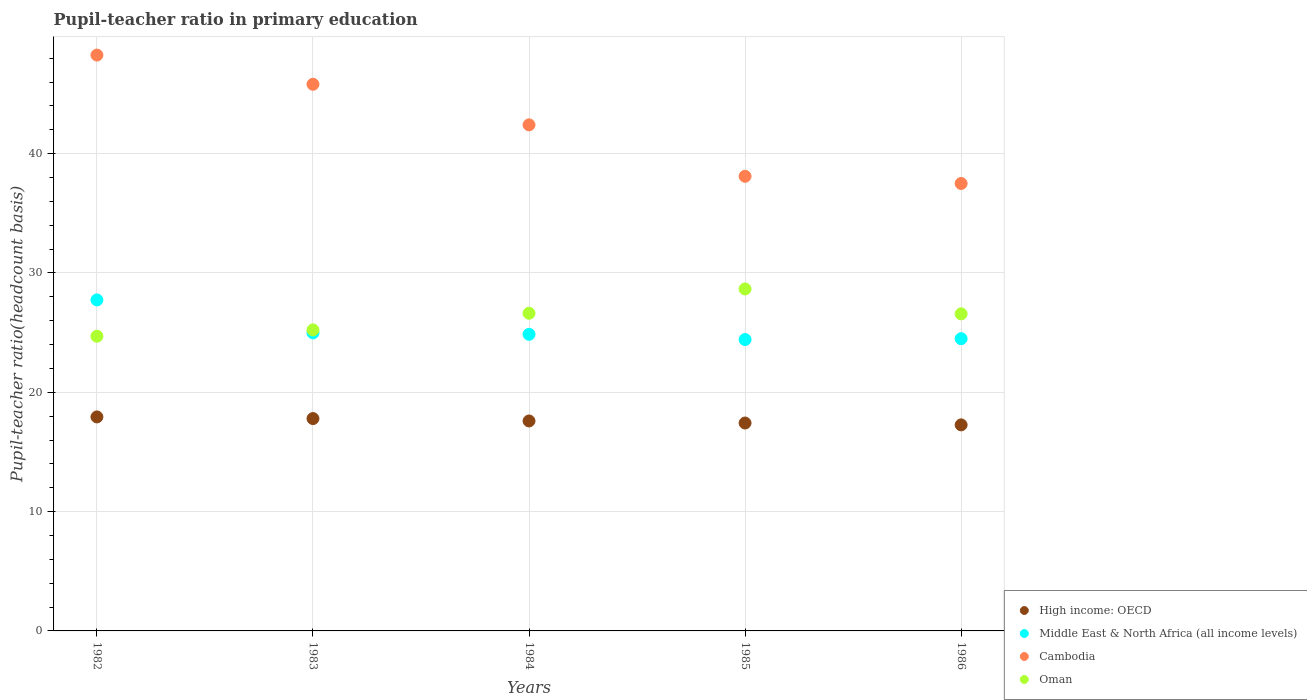What is the pupil-teacher ratio in primary education in Cambodia in 1983?
Keep it short and to the point. 45.82. Across all years, what is the maximum pupil-teacher ratio in primary education in Middle East & North Africa (all income levels)?
Your answer should be very brief. 27.74. Across all years, what is the minimum pupil-teacher ratio in primary education in Oman?
Provide a short and direct response. 24.7. In which year was the pupil-teacher ratio in primary education in High income: OECD maximum?
Give a very brief answer. 1982. In which year was the pupil-teacher ratio in primary education in Cambodia minimum?
Make the answer very short. 1986. What is the total pupil-teacher ratio in primary education in Cambodia in the graph?
Provide a succinct answer. 212.1. What is the difference between the pupil-teacher ratio in primary education in Middle East & North Africa (all income levels) in 1982 and that in 1983?
Provide a succinct answer. 2.76. What is the difference between the pupil-teacher ratio in primary education in Oman in 1985 and the pupil-teacher ratio in primary education in Cambodia in 1983?
Offer a terse response. -17.15. What is the average pupil-teacher ratio in primary education in Middle East & North Africa (all income levels) per year?
Ensure brevity in your answer.  25.3. In the year 1984, what is the difference between the pupil-teacher ratio in primary education in Middle East & North Africa (all income levels) and pupil-teacher ratio in primary education in Oman?
Ensure brevity in your answer.  -1.77. In how many years, is the pupil-teacher ratio in primary education in High income: OECD greater than 44?
Provide a succinct answer. 0. What is the ratio of the pupil-teacher ratio in primary education in Cambodia in 1982 to that in 1984?
Provide a succinct answer. 1.14. Is the pupil-teacher ratio in primary education in Middle East & North Africa (all income levels) in 1984 less than that in 1986?
Your answer should be compact. No. What is the difference between the highest and the second highest pupil-teacher ratio in primary education in High income: OECD?
Offer a very short reply. 0.14. What is the difference between the highest and the lowest pupil-teacher ratio in primary education in Cambodia?
Your response must be concise. 10.76. Is the sum of the pupil-teacher ratio in primary education in Cambodia in 1983 and 1985 greater than the maximum pupil-teacher ratio in primary education in Middle East & North Africa (all income levels) across all years?
Offer a terse response. Yes. Is it the case that in every year, the sum of the pupil-teacher ratio in primary education in Oman and pupil-teacher ratio in primary education in Cambodia  is greater than the sum of pupil-teacher ratio in primary education in Middle East & North Africa (all income levels) and pupil-teacher ratio in primary education in High income: OECD?
Keep it short and to the point. Yes. How many dotlines are there?
Your answer should be compact. 4. How many years are there in the graph?
Your answer should be compact. 5. Does the graph contain any zero values?
Make the answer very short. No. Does the graph contain grids?
Your response must be concise. Yes. Where does the legend appear in the graph?
Offer a terse response. Bottom right. How many legend labels are there?
Give a very brief answer. 4. How are the legend labels stacked?
Offer a terse response. Vertical. What is the title of the graph?
Make the answer very short. Pupil-teacher ratio in primary education. Does "Guatemala" appear as one of the legend labels in the graph?
Keep it short and to the point. No. What is the label or title of the X-axis?
Offer a very short reply. Years. What is the label or title of the Y-axis?
Keep it short and to the point. Pupil-teacher ratio(headcount basis). What is the Pupil-teacher ratio(headcount basis) of High income: OECD in 1982?
Offer a very short reply. 17.94. What is the Pupil-teacher ratio(headcount basis) in Middle East & North Africa (all income levels) in 1982?
Give a very brief answer. 27.74. What is the Pupil-teacher ratio(headcount basis) of Cambodia in 1982?
Your answer should be compact. 48.26. What is the Pupil-teacher ratio(headcount basis) of Oman in 1982?
Your answer should be compact. 24.7. What is the Pupil-teacher ratio(headcount basis) of High income: OECD in 1983?
Keep it short and to the point. 17.8. What is the Pupil-teacher ratio(headcount basis) in Middle East & North Africa (all income levels) in 1983?
Your response must be concise. 24.98. What is the Pupil-teacher ratio(headcount basis) of Cambodia in 1983?
Ensure brevity in your answer.  45.82. What is the Pupil-teacher ratio(headcount basis) of Oman in 1983?
Give a very brief answer. 25.23. What is the Pupil-teacher ratio(headcount basis) of High income: OECD in 1984?
Offer a very short reply. 17.6. What is the Pupil-teacher ratio(headcount basis) in Middle East & North Africa (all income levels) in 1984?
Give a very brief answer. 24.86. What is the Pupil-teacher ratio(headcount basis) of Cambodia in 1984?
Provide a succinct answer. 42.41. What is the Pupil-teacher ratio(headcount basis) in Oman in 1984?
Offer a terse response. 26.63. What is the Pupil-teacher ratio(headcount basis) in High income: OECD in 1985?
Keep it short and to the point. 17.42. What is the Pupil-teacher ratio(headcount basis) of Middle East & North Africa (all income levels) in 1985?
Ensure brevity in your answer.  24.42. What is the Pupil-teacher ratio(headcount basis) in Cambodia in 1985?
Make the answer very short. 38.1. What is the Pupil-teacher ratio(headcount basis) of Oman in 1985?
Give a very brief answer. 28.66. What is the Pupil-teacher ratio(headcount basis) of High income: OECD in 1986?
Give a very brief answer. 17.27. What is the Pupil-teacher ratio(headcount basis) of Middle East & North Africa (all income levels) in 1986?
Offer a terse response. 24.49. What is the Pupil-teacher ratio(headcount basis) of Cambodia in 1986?
Make the answer very short. 37.5. What is the Pupil-teacher ratio(headcount basis) of Oman in 1986?
Make the answer very short. 26.57. Across all years, what is the maximum Pupil-teacher ratio(headcount basis) of High income: OECD?
Your response must be concise. 17.94. Across all years, what is the maximum Pupil-teacher ratio(headcount basis) of Middle East & North Africa (all income levels)?
Your response must be concise. 27.74. Across all years, what is the maximum Pupil-teacher ratio(headcount basis) in Cambodia?
Offer a very short reply. 48.26. Across all years, what is the maximum Pupil-teacher ratio(headcount basis) in Oman?
Offer a terse response. 28.66. Across all years, what is the minimum Pupil-teacher ratio(headcount basis) in High income: OECD?
Provide a succinct answer. 17.27. Across all years, what is the minimum Pupil-teacher ratio(headcount basis) in Middle East & North Africa (all income levels)?
Provide a short and direct response. 24.42. Across all years, what is the minimum Pupil-teacher ratio(headcount basis) in Cambodia?
Your response must be concise. 37.5. Across all years, what is the minimum Pupil-teacher ratio(headcount basis) of Oman?
Provide a short and direct response. 24.7. What is the total Pupil-teacher ratio(headcount basis) in High income: OECD in the graph?
Your answer should be very brief. 88.02. What is the total Pupil-teacher ratio(headcount basis) of Middle East & North Africa (all income levels) in the graph?
Offer a very short reply. 126.49. What is the total Pupil-teacher ratio(headcount basis) of Cambodia in the graph?
Ensure brevity in your answer.  212.1. What is the total Pupil-teacher ratio(headcount basis) in Oman in the graph?
Your answer should be very brief. 131.79. What is the difference between the Pupil-teacher ratio(headcount basis) of High income: OECD in 1982 and that in 1983?
Keep it short and to the point. 0.14. What is the difference between the Pupil-teacher ratio(headcount basis) of Middle East & North Africa (all income levels) in 1982 and that in 1983?
Make the answer very short. 2.76. What is the difference between the Pupil-teacher ratio(headcount basis) in Cambodia in 1982 and that in 1983?
Ensure brevity in your answer.  2.45. What is the difference between the Pupil-teacher ratio(headcount basis) of Oman in 1982 and that in 1983?
Give a very brief answer. -0.53. What is the difference between the Pupil-teacher ratio(headcount basis) in High income: OECD in 1982 and that in 1984?
Make the answer very short. 0.34. What is the difference between the Pupil-teacher ratio(headcount basis) in Middle East & North Africa (all income levels) in 1982 and that in 1984?
Give a very brief answer. 2.88. What is the difference between the Pupil-teacher ratio(headcount basis) in Cambodia in 1982 and that in 1984?
Your answer should be compact. 5.85. What is the difference between the Pupil-teacher ratio(headcount basis) of Oman in 1982 and that in 1984?
Offer a very short reply. -1.93. What is the difference between the Pupil-teacher ratio(headcount basis) of High income: OECD in 1982 and that in 1985?
Make the answer very short. 0.51. What is the difference between the Pupil-teacher ratio(headcount basis) of Middle East & North Africa (all income levels) in 1982 and that in 1985?
Offer a very short reply. 3.32. What is the difference between the Pupil-teacher ratio(headcount basis) of Cambodia in 1982 and that in 1985?
Provide a short and direct response. 10.16. What is the difference between the Pupil-teacher ratio(headcount basis) of Oman in 1982 and that in 1985?
Make the answer very short. -3.96. What is the difference between the Pupil-teacher ratio(headcount basis) in High income: OECD in 1982 and that in 1986?
Give a very brief answer. 0.67. What is the difference between the Pupil-teacher ratio(headcount basis) of Middle East & North Africa (all income levels) in 1982 and that in 1986?
Ensure brevity in your answer.  3.25. What is the difference between the Pupil-teacher ratio(headcount basis) in Cambodia in 1982 and that in 1986?
Keep it short and to the point. 10.76. What is the difference between the Pupil-teacher ratio(headcount basis) of Oman in 1982 and that in 1986?
Your answer should be very brief. -1.87. What is the difference between the Pupil-teacher ratio(headcount basis) in High income: OECD in 1983 and that in 1984?
Your answer should be very brief. 0.2. What is the difference between the Pupil-teacher ratio(headcount basis) of Middle East & North Africa (all income levels) in 1983 and that in 1984?
Make the answer very short. 0.12. What is the difference between the Pupil-teacher ratio(headcount basis) of Cambodia in 1983 and that in 1984?
Your response must be concise. 3.4. What is the difference between the Pupil-teacher ratio(headcount basis) in Oman in 1983 and that in 1984?
Give a very brief answer. -1.4. What is the difference between the Pupil-teacher ratio(headcount basis) in High income: OECD in 1983 and that in 1985?
Your answer should be very brief. 0.37. What is the difference between the Pupil-teacher ratio(headcount basis) in Middle East & North Africa (all income levels) in 1983 and that in 1985?
Keep it short and to the point. 0.56. What is the difference between the Pupil-teacher ratio(headcount basis) of Cambodia in 1983 and that in 1985?
Keep it short and to the point. 7.71. What is the difference between the Pupil-teacher ratio(headcount basis) of Oman in 1983 and that in 1985?
Your response must be concise. -3.43. What is the difference between the Pupil-teacher ratio(headcount basis) of High income: OECD in 1983 and that in 1986?
Offer a very short reply. 0.53. What is the difference between the Pupil-teacher ratio(headcount basis) in Middle East & North Africa (all income levels) in 1983 and that in 1986?
Your answer should be compact. 0.49. What is the difference between the Pupil-teacher ratio(headcount basis) of Cambodia in 1983 and that in 1986?
Provide a succinct answer. 8.31. What is the difference between the Pupil-teacher ratio(headcount basis) of Oman in 1983 and that in 1986?
Provide a succinct answer. -1.34. What is the difference between the Pupil-teacher ratio(headcount basis) of High income: OECD in 1984 and that in 1985?
Keep it short and to the point. 0.17. What is the difference between the Pupil-teacher ratio(headcount basis) of Middle East & North Africa (all income levels) in 1984 and that in 1985?
Make the answer very short. 0.44. What is the difference between the Pupil-teacher ratio(headcount basis) of Cambodia in 1984 and that in 1985?
Keep it short and to the point. 4.31. What is the difference between the Pupil-teacher ratio(headcount basis) of Oman in 1984 and that in 1985?
Your answer should be very brief. -2.04. What is the difference between the Pupil-teacher ratio(headcount basis) of High income: OECD in 1984 and that in 1986?
Offer a terse response. 0.33. What is the difference between the Pupil-teacher ratio(headcount basis) of Middle East & North Africa (all income levels) in 1984 and that in 1986?
Provide a succinct answer. 0.37. What is the difference between the Pupil-teacher ratio(headcount basis) of Cambodia in 1984 and that in 1986?
Provide a short and direct response. 4.91. What is the difference between the Pupil-teacher ratio(headcount basis) of Oman in 1984 and that in 1986?
Provide a short and direct response. 0.05. What is the difference between the Pupil-teacher ratio(headcount basis) in High income: OECD in 1985 and that in 1986?
Your response must be concise. 0.16. What is the difference between the Pupil-teacher ratio(headcount basis) in Middle East & North Africa (all income levels) in 1985 and that in 1986?
Offer a terse response. -0.07. What is the difference between the Pupil-teacher ratio(headcount basis) in Cambodia in 1985 and that in 1986?
Provide a succinct answer. 0.6. What is the difference between the Pupil-teacher ratio(headcount basis) in Oman in 1985 and that in 1986?
Your response must be concise. 2.09. What is the difference between the Pupil-teacher ratio(headcount basis) of High income: OECD in 1982 and the Pupil-teacher ratio(headcount basis) of Middle East & North Africa (all income levels) in 1983?
Keep it short and to the point. -7.04. What is the difference between the Pupil-teacher ratio(headcount basis) of High income: OECD in 1982 and the Pupil-teacher ratio(headcount basis) of Cambodia in 1983?
Give a very brief answer. -27.88. What is the difference between the Pupil-teacher ratio(headcount basis) of High income: OECD in 1982 and the Pupil-teacher ratio(headcount basis) of Oman in 1983?
Your answer should be compact. -7.29. What is the difference between the Pupil-teacher ratio(headcount basis) in Middle East & North Africa (all income levels) in 1982 and the Pupil-teacher ratio(headcount basis) in Cambodia in 1983?
Your answer should be compact. -18.07. What is the difference between the Pupil-teacher ratio(headcount basis) of Middle East & North Africa (all income levels) in 1982 and the Pupil-teacher ratio(headcount basis) of Oman in 1983?
Offer a very short reply. 2.51. What is the difference between the Pupil-teacher ratio(headcount basis) of Cambodia in 1982 and the Pupil-teacher ratio(headcount basis) of Oman in 1983?
Provide a succinct answer. 23.03. What is the difference between the Pupil-teacher ratio(headcount basis) of High income: OECD in 1982 and the Pupil-teacher ratio(headcount basis) of Middle East & North Africa (all income levels) in 1984?
Offer a terse response. -6.92. What is the difference between the Pupil-teacher ratio(headcount basis) in High income: OECD in 1982 and the Pupil-teacher ratio(headcount basis) in Cambodia in 1984?
Give a very brief answer. -24.48. What is the difference between the Pupil-teacher ratio(headcount basis) of High income: OECD in 1982 and the Pupil-teacher ratio(headcount basis) of Oman in 1984?
Provide a succinct answer. -8.69. What is the difference between the Pupil-teacher ratio(headcount basis) in Middle East & North Africa (all income levels) in 1982 and the Pupil-teacher ratio(headcount basis) in Cambodia in 1984?
Give a very brief answer. -14.67. What is the difference between the Pupil-teacher ratio(headcount basis) in Middle East & North Africa (all income levels) in 1982 and the Pupil-teacher ratio(headcount basis) in Oman in 1984?
Your response must be concise. 1.12. What is the difference between the Pupil-teacher ratio(headcount basis) of Cambodia in 1982 and the Pupil-teacher ratio(headcount basis) of Oman in 1984?
Keep it short and to the point. 21.64. What is the difference between the Pupil-teacher ratio(headcount basis) in High income: OECD in 1982 and the Pupil-teacher ratio(headcount basis) in Middle East & North Africa (all income levels) in 1985?
Provide a succinct answer. -6.48. What is the difference between the Pupil-teacher ratio(headcount basis) of High income: OECD in 1982 and the Pupil-teacher ratio(headcount basis) of Cambodia in 1985?
Your answer should be very brief. -20.17. What is the difference between the Pupil-teacher ratio(headcount basis) in High income: OECD in 1982 and the Pupil-teacher ratio(headcount basis) in Oman in 1985?
Make the answer very short. -10.72. What is the difference between the Pupil-teacher ratio(headcount basis) in Middle East & North Africa (all income levels) in 1982 and the Pupil-teacher ratio(headcount basis) in Cambodia in 1985?
Give a very brief answer. -10.36. What is the difference between the Pupil-teacher ratio(headcount basis) in Middle East & North Africa (all income levels) in 1982 and the Pupil-teacher ratio(headcount basis) in Oman in 1985?
Offer a very short reply. -0.92. What is the difference between the Pupil-teacher ratio(headcount basis) in Cambodia in 1982 and the Pupil-teacher ratio(headcount basis) in Oman in 1985?
Make the answer very short. 19.6. What is the difference between the Pupil-teacher ratio(headcount basis) in High income: OECD in 1982 and the Pupil-teacher ratio(headcount basis) in Middle East & North Africa (all income levels) in 1986?
Your response must be concise. -6.56. What is the difference between the Pupil-teacher ratio(headcount basis) in High income: OECD in 1982 and the Pupil-teacher ratio(headcount basis) in Cambodia in 1986?
Ensure brevity in your answer.  -19.56. What is the difference between the Pupil-teacher ratio(headcount basis) of High income: OECD in 1982 and the Pupil-teacher ratio(headcount basis) of Oman in 1986?
Give a very brief answer. -8.64. What is the difference between the Pupil-teacher ratio(headcount basis) of Middle East & North Africa (all income levels) in 1982 and the Pupil-teacher ratio(headcount basis) of Cambodia in 1986?
Make the answer very short. -9.76. What is the difference between the Pupil-teacher ratio(headcount basis) in Middle East & North Africa (all income levels) in 1982 and the Pupil-teacher ratio(headcount basis) in Oman in 1986?
Offer a terse response. 1.17. What is the difference between the Pupil-teacher ratio(headcount basis) of Cambodia in 1982 and the Pupil-teacher ratio(headcount basis) of Oman in 1986?
Make the answer very short. 21.69. What is the difference between the Pupil-teacher ratio(headcount basis) in High income: OECD in 1983 and the Pupil-teacher ratio(headcount basis) in Middle East & North Africa (all income levels) in 1984?
Ensure brevity in your answer.  -7.06. What is the difference between the Pupil-teacher ratio(headcount basis) of High income: OECD in 1983 and the Pupil-teacher ratio(headcount basis) of Cambodia in 1984?
Give a very brief answer. -24.62. What is the difference between the Pupil-teacher ratio(headcount basis) in High income: OECD in 1983 and the Pupil-teacher ratio(headcount basis) in Oman in 1984?
Your response must be concise. -8.83. What is the difference between the Pupil-teacher ratio(headcount basis) in Middle East & North Africa (all income levels) in 1983 and the Pupil-teacher ratio(headcount basis) in Cambodia in 1984?
Offer a terse response. -17.44. What is the difference between the Pupil-teacher ratio(headcount basis) in Middle East & North Africa (all income levels) in 1983 and the Pupil-teacher ratio(headcount basis) in Oman in 1984?
Your response must be concise. -1.65. What is the difference between the Pupil-teacher ratio(headcount basis) of Cambodia in 1983 and the Pupil-teacher ratio(headcount basis) of Oman in 1984?
Offer a very short reply. 19.19. What is the difference between the Pupil-teacher ratio(headcount basis) of High income: OECD in 1983 and the Pupil-teacher ratio(headcount basis) of Middle East & North Africa (all income levels) in 1985?
Offer a very short reply. -6.62. What is the difference between the Pupil-teacher ratio(headcount basis) in High income: OECD in 1983 and the Pupil-teacher ratio(headcount basis) in Cambodia in 1985?
Offer a very short reply. -20.31. What is the difference between the Pupil-teacher ratio(headcount basis) of High income: OECD in 1983 and the Pupil-teacher ratio(headcount basis) of Oman in 1985?
Keep it short and to the point. -10.86. What is the difference between the Pupil-teacher ratio(headcount basis) in Middle East & North Africa (all income levels) in 1983 and the Pupil-teacher ratio(headcount basis) in Cambodia in 1985?
Offer a terse response. -13.13. What is the difference between the Pupil-teacher ratio(headcount basis) of Middle East & North Africa (all income levels) in 1983 and the Pupil-teacher ratio(headcount basis) of Oman in 1985?
Your answer should be very brief. -3.68. What is the difference between the Pupil-teacher ratio(headcount basis) in Cambodia in 1983 and the Pupil-teacher ratio(headcount basis) in Oman in 1985?
Provide a short and direct response. 17.15. What is the difference between the Pupil-teacher ratio(headcount basis) in High income: OECD in 1983 and the Pupil-teacher ratio(headcount basis) in Middle East & North Africa (all income levels) in 1986?
Offer a terse response. -6.7. What is the difference between the Pupil-teacher ratio(headcount basis) of High income: OECD in 1983 and the Pupil-teacher ratio(headcount basis) of Cambodia in 1986?
Provide a short and direct response. -19.7. What is the difference between the Pupil-teacher ratio(headcount basis) of High income: OECD in 1983 and the Pupil-teacher ratio(headcount basis) of Oman in 1986?
Your response must be concise. -8.78. What is the difference between the Pupil-teacher ratio(headcount basis) of Middle East & North Africa (all income levels) in 1983 and the Pupil-teacher ratio(headcount basis) of Cambodia in 1986?
Offer a terse response. -12.52. What is the difference between the Pupil-teacher ratio(headcount basis) in Middle East & North Africa (all income levels) in 1983 and the Pupil-teacher ratio(headcount basis) in Oman in 1986?
Your response must be concise. -1.6. What is the difference between the Pupil-teacher ratio(headcount basis) in Cambodia in 1983 and the Pupil-teacher ratio(headcount basis) in Oman in 1986?
Keep it short and to the point. 19.24. What is the difference between the Pupil-teacher ratio(headcount basis) of High income: OECD in 1984 and the Pupil-teacher ratio(headcount basis) of Middle East & North Africa (all income levels) in 1985?
Your answer should be very brief. -6.82. What is the difference between the Pupil-teacher ratio(headcount basis) in High income: OECD in 1984 and the Pupil-teacher ratio(headcount basis) in Cambodia in 1985?
Offer a very short reply. -20.51. What is the difference between the Pupil-teacher ratio(headcount basis) in High income: OECD in 1984 and the Pupil-teacher ratio(headcount basis) in Oman in 1985?
Offer a terse response. -11.06. What is the difference between the Pupil-teacher ratio(headcount basis) of Middle East & North Africa (all income levels) in 1984 and the Pupil-teacher ratio(headcount basis) of Cambodia in 1985?
Your answer should be very brief. -13.24. What is the difference between the Pupil-teacher ratio(headcount basis) of Middle East & North Africa (all income levels) in 1984 and the Pupil-teacher ratio(headcount basis) of Oman in 1985?
Keep it short and to the point. -3.8. What is the difference between the Pupil-teacher ratio(headcount basis) of Cambodia in 1984 and the Pupil-teacher ratio(headcount basis) of Oman in 1985?
Provide a short and direct response. 13.75. What is the difference between the Pupil-teacher ratio(headcount basis) of High income: OECD in 1984 and the Pupil-teacher ratio(headcount basis) of Middle East & North Africa (all income levels) in 1986?
Your answer should be compact. -6.9. What is the difference between the Pupil-teacher ratio(headcount basis) in High income: OECD in 1984 and the Pupil-teacher ratio(headcount basis) in Cambodia in 1986?
Keep it short and to the point. -19.9. What is the difference between the Pupil-teacher ratio(headcount basis) in High income: OECD in 1984 and the Pupil-teacher ratio(headcount basis) in Oman in 1986?
Give a very brief answer. -8.98. What is the difference between the Pupil-teacher ratio(headcount basis) in Middle East & North Africa (all income levels) in 1984 and the Pupil-teacher ratio(headcount basis) in Cambodia in 1986?
Provide a succinct answer. -12.64. What is the difference between the Pupil-teacher ratio(headcount basis) of Middle East & North Africa (all income levels) in 1984 and the Pupil-teacher ratio(headcount basis) of Oman in 1986?
Offer a very short reply. -1.72. What is the difference between the Pupil-teacher ratio(headcount basis) in Cambodia in 1984 and the Pupil-teacher ratio(headcount basis) in Oman in 1986?
Keep it short and to the point. 15.84. What is the difference between the Pupil-teacher ratio(headcount basis) in High income: OECD in 1985 and the Pupil-teacher ratio(headcount basis) in Middle East & North Africa (all income levels) in 1986?
Offer a very short reply. -7.07. What is the difference between the Pupil-teacher ratio(headcount basis) of High income: OECD in 1985 and the Pupil-teacher ratio(headcount basis) of Cambodia in 1986?
Your answer should be very brief. -20.08. What is the difference between the Pupil-teacher ratio(headcount basis) in High income: OECD in 1985 and the Pupil-teacher ratio(headcount basis) in Oman in 1986?
Keep it short and to the point. -9.15. What is the difference between the Pupil-teacher ratio(headcount basis) in Middle East & North Africa (all income levels) in 1985 and the Pupil-teacher ratio(headcount basis) in Cambodia in 1986?
Provide a succinct answer. -13.08. What is the difference between the Pupil-teacher ratio(headcount basis) in Middle East & North Africa (all income levels) in 1985 and the Pupil-teacher ratio(headcount basis) in Oman in 1986?
Your answer should be very brief. -2.15. What is the difference between the Pupil-teacher ratio(headcount basis) in Cambodia in 1985 and the Pupil-teacher ratio(headcount basis) in Oman in 1986?
Make the answer very short. 11.53. What is the average Pupil-teacher ratio(headcount basis) in High income: OECD per year?
Provide a short and direct response. 17.6. What is the average Pupil-teacher ratio(headcount basis) in Middle East & North Africa (all income levels) per year?
Ensure brevity in your answer.  25.3. What is the average Pupil-teacher ratio(headcount basis) of Cambodia per year?
Your response must be concise. 42.42. What is the average Pupil-teacher ratio(headcount basis) in Oman per year?
Your response must be concise. 26.36. In the year 1982, what is the difference between the Pupil-teacher ratio(headcount basis) of High income: OECD and Pupil-teacher ratio(headcount basis) of Middle East & North Africa (all income levels)?
Your answer should be compact. -9.8. In the year 1982, what is the difference between the Pupil-teacher ratio(headcount basis) in High income: OECD and Pupil-teacher ratio(headcount basis) in Cambodia?
Ensure brevity in your answer.  -30.33. In the year 1982, what is the difference between the Pupil-teacher ratio(headcount basis) in High income: OECD and Pupil-teacher ratio(headcount basis) in Oman?
Ensure brevity in your answer.  -6.76. In the year 1982, what is the difference between the Pupil-teacher ratio(headcount basis) in Middle East & North Africa (all income levels) and Pupil-teacher ratio(headcount basis) in Cambodia?
Your response must be concise. -20.52. In the year 1982, what is the difference between the Pupil-teacher ratio(headcount basis) in Middle East & North Africa (all income levels) and Pupil-teacher ratio(headcount basis) in Oman?
Give a very brief answer. 3.04. In the year 1982, what is the difference between the Pupil-teacher ratio(headcount basis) in Cambodia and Pupil-teacher ratio(headcount basis) in Oman?
Keep it short and to the point. 23.56. In the year 1983, what is the difference between the Pupil-teacher ratio(headcount basis) in High income: OECD and Pupil-teacher ratio(headcount basis) in Middle East & North Africa (all income levels)?
Your response must be concise. -7.18. In the year 1983, what is the difference between the Pupil-teacher ratio(headcount basis) of High income: OECD and Pupil-teacher ratio(headcount basis) of Cambodia?
Give a very brief answer. -28.02. In the year 1983, what is the difference between the Pupil-teacher ratio(headcount basis) in High income: OECD and Pupil-teacher ratio(headcount basis) in Oman?
Offer a terse response. -7.43. In the year 1983, what is the difference between the Pupil-teacher ratio(headcount basis) in Middle East & North Africa (all income levels) and Pupil-teacher ratio(headcount basis) in Cambodia?
Your answer should be very brief. -20.84. In the year 1983, what is the difference between the Pupil-teacher ratio(headcount basis) in Middle East & North Africa (all income levels) and Pupil-teacher ratio(headcount basis) in Oman?
Offer a very short reply. -0.25. In the year 1983, what is the difference between the Pupil-teacher ratio(headcount basis) of Cambodia and Pupil-teacher ratio(headcount basis) of Oman?
Keep it short and to the point. 20.59. In the year 1984, what is the difference between the Pupil-teacher ratio(headcount basis) of High income: OECD and Pupil-teacher ratio(headcount basis) of Middle East & North Africa (all income levels)?
Keep it short and to the point. -7.26. In the year 1984, what is the difference between the Pupil-teacher ratio(headcount basis) of High income: OECD and Pupil-teacher ratio(headcount basis) of Cambodia?
Provide a succinct answer. -24.82. In the year 1984, what is the difference between the Pupil-teacher ratio(headcount basis) in High income: OECD and Pupil-teacher ratio(headcount basis) in Oman?
Provide a succinct answer. -9.03. In the year 1984, what is the difference between the Pupil-teacher ratio(headcount basis) of Middle East & North Africa (all income levels) and Pupil-teacher ratio(headcount basis) of Cambodia?
Ensure brevity in your answer.  -17.56. In the year 1984, what is the difference between the Pupil-teacher ratio(headcount basis) of Middle East & North Africa (all income levels) and Pupil-teacher ratio(headcount basis) of Oman?
Your answer should be compact. -1.77. In the year 1984, what is the difference between the Pupil-teacher ratio(headcount basis) of Cambodia and Pupil-teacher ratio(headcount basis) of Oman?
Give a very brief answer. 15.79. In the year 1985, what is the difference between the Pupil-teacher ratio(headcount basis) of High income: OECD and Pupil-teacher ratio(headcount basis) of Middle East & North Africa (all income levels)?
Give a very brief answer. -7. In the year 1985, what is the difference between the Pupil-teacher ratio(headcount basis) in High income: OECD and Pupil-teacher ratio(headcount basis) in Cambodia?
Your response must be concise. -20.68. In the year 1985, what is the difference between the Pupil-teacher ratio(headcount basis) in High income: OECD and Pupil-teacher ratio(headcount basis) in Oman?
Provide a short and direct response. -11.24. In the year 1985, what is the difference between the Pupil-teacher ratio(headcount basis) in Middle East & North Africa (all income levels) and Pupil-teacher ratio(headcount basis) in Cambodia?
Give a very brief answer. -13.68. In the year 1985, what is the difference between the Pupil-teacher ratio(headcount basis) of Middle East & North Africa (all income levels) and Pupil-teacher ratio(headcount basis) of Oman?
Offer a very short reply. -4.24. In the year 1985, what is the difference between the Pupil-teacher ratio(headcount basis) in Cambodia and Pupil-teacher ratio(headcount basis) in Oman?
Provide a succinct answer. 9.44. In the year 1986, what is the difference between the Pupil-teacher ratio(headcount basis) in High income: OECD and Pupil-teacher ratio(headcount basis) in Middle East & North Africa (all income levels)?
Make the answer very short. -7.22. In the year 1986, what is the difference between the Pupil-teacher ratio(headcount basis) of High income: OECD and Pupil-teacher ratio(headcount basis) of Cambodia?
Provide a succinct answer. -20.23. In the year 1986, what is the difference between the Pupil-teacher ratio(headcount basis) in High income: OECD and Pupil-teacher ratio(headcount basis) in Oman?
Make the answer very short. -9.31. In the year 1986, what is the difference between the Pupil-teacher ratio(headcount basis) in Middle East & North Africa (all income levels) and Pupil-teacher ratio(headcount basis) in Cambodia?
Make the answer very short. -13.01. In the year 1986, what is the difference between the Pupil-teacher ratio(headcount basis) in Middle East & North Africa (all income levels) and Pupil-teacher ratio(headcount basis) in Oman?
Ensure brevity in your answer.  -2.08. In the year 1986, what is the difference between the Pupil-teacher ratio(headcount basis) of Cambodia and Pupil-teacher ratio(headcount basis) of Oman?
Offer a terse response. 10.93. What is the ratio of the Pupil-teacher ratio(headcount basis) in Middle East & North Africa (all income levels) in 1982 to that in 1983?
Your answer should be compact. 1.11. What is the ratio of the Pupil-teacher ratio(headcount basis) in Cambodia in 1982 to that in 1983?
Offer a terse response. 1.05. What is the ratio of the Pupil-teacher ratio(headcount basis) in High income: OECD in 1982 to that in 1984?
Keep it short and to the point. 1.02. What is the ratio of the Pupil-teacher ratio(headcount basis) in Middle East & North Africa (all income levels) in 1982 to that in 1984?
Your answer should be compact. 1.12. What is the ratio of the Pupil-teacher ratio(headcount basis) in Cambodia in 1982 to that in 1984?
Make the answer very short. 1.14. What is the ratio of the Pupil-teacher ratio(headcount basis) of Oman in 1982 to that in 1984?
Provide a succinct answer. 0.93. What is the ratio of the Pupil-teacher ratio(headcount basis) in High income: OECD in 1982 to that in 1985?
Ensure brevity in your answer.  1.03. What is the ratio of the Pupil-teacher ratio(headcount basis) in Middle East & North Africa (all income levels) in 1982 to that in 1985?
Make the answer very short. 1.14. What is the ratio of the Pupil-teacher ratio(headcount basis) in Cambodia in 1982 to that in 1985?
Your answer should be very brief. 1.27. What is the ratio of the Pupil-teacher ratio(headcount basis) of Oman in 1982 to that in 1985?
Offer a terse response. 0.86. What is the ratio of the Pupil-teacher ratio(headcount basis) in High income: OECD in 1982 to that in 1986?
Your response must be concise. 1.04. What is the ratio of the Pupil-teacher ratio(headcount basis) of Middle East & North Africa (all income levels) in 1982 to that in 1986?
Your answer should be compact. 1.13. What is the ratio of the Pupil-teacher ratio(headcount basis) in Cambodia in 1982 to that in 1986?
Give a very brief answer. 1.29. What is the ratio of the Pupil-teacher ratio(headcount basis) in Oman in 1982 to that in 1986?
Your answer should be compact. 0.93. What is the ratio of the Pupil-teacher ratio(headcount basis) in High income: OECD in 1983 to that in 1984?
Ensure brevity in your answer.  1.01. What is the ratio of the Pupil-teacher ratio(headcount basis) in Middle East & North Africa (all income levels) in 1983 to that in 1984?
Offer a terse response. 1. What is the ratio of the Pupil-teacher ratio(headcount basis) of Cambodia in 1983 to that in 1984?
Keep it short and to the point. 1.08. What is the ratio of the Pupil-teacher ratio(headcount basis) of Oman in 1983 to that in 1984?
Provide a succinct answer. 0.95. What is the ratio of the Pupil-teacher ratio(headcount basis) in High income: OECD in 1983 to that in 1985?
Provide a succinct answer. 1.02. What is the ratio of the Pupil-teacher ratio(headcount basis) in Middle East & North Africa (all income levels) in 1983 to that in 1985?
Your answer should be very brief. 1.02. What is the ratio of the Pupil-teacher ratio(headcount basis) of Cambodia in 1983 to that in 1985?
Your answer should be very brief. 1.2. What is the ratio of the Pupil-teacher ratio(headcount basis) of Oman in 1983 to that in 1985?
Your answer should be compact. 0.88. What is the ratio of the Pupil-teacher ratio(headcount basis) in High income: OECD in 1983 to that in 1986?
Give a very brief answer. 1.03. What is the ratio of the Pupil-teacher ratio(headcount basis) in Middle East & North Africa (all income levels) in 1983 to that in 1986?
Provide a succinct answer. 1.02. What is the ratio of the Pupil-teacher ratio(headcount basis) of Cambodia in 1983 to that in 1986?
Your answer should be very brief. 1.22. What is the ratio of the Pupil-teacher ratio(headcount basis) of Oman in 1983 to that in 1986?
Keep it short and to the point. 0.95. What is the ratio of the Pupil-teacher ratio(headcount basis) in High income: OECD in 1984 to that in 1985?
Your answer should be very brief. 1.01. What is the ratio of the Pupil-teacher ratio(headcount basis) in Middle East & North Africa (all income levels) in 1984 to that in 1985?
Your response must be concise. 1.02. What is the ratio of the Pupil-teacher ratio(headcount basis) in Cambodia in 1984 to that in 1985?
Offer a very short reply. 1.11. What is the ratio of the Pupil-teacher ratio(headcount basis) of Oman in 1984 to that in 1985?
Offer a very short reply. 0.93. What is the ratio of the Pupil-teacher ratio(headcount basis) in High income: OECD in 1984 to that in 1986?
Keep it short and to the point. 1.02. What is the ratio of the Pupil-teacher ratio(headcount basis) in Middle East & North Africa (all income levels) in 1984 to that in 1986?
Give a very brief answer. 1.01. What is the ratio of the Pupil-teacher ratio(headcount basis) of Cambodia in 1984 to that in 1986?
Keep it short and to the point. 1.13. What is the ratio of the Pupil-teacher ratio(headcount basis) in Oman in 1984 to that in 1986?
Provide a succinct answer. 1. What is the ratio of the Pupil-teacher ratio(headcount basis) of Cambodia in 1985 to that in 1986?
Provide a succinct answer. 1.02. What is the ratio of the Pupil-teacher ratio(headcount basis) of Oman in 1985 to that in 1986?
Your answer should be very brief. 1.08. What is the difference between the highest and the second highest Pupil-teacher ratio(headcount basis) of High income: OECD?
Provide a succinct answer. 0.14. What is the difference between the highest and the second highest Pupil-teacher ratio(headcount basis) in Middle East & North Africa (all income levels)?
Offer a very short reply. 2.76. What is the difference between the highest and the second highest Pupil-teacher ratio(headcount basis) of Cambodia?
Keep it short and to the point. 2.45. What is the difference between the highest and the second highest Pupil-teacher ratio(headcount basis) in Oman?
Keep it short and to the point. 2.04. What is the difference between the highest and the lowest Pupil-teacher ratio(headcount basis) of High income: OECD?
Make the answer very short. 0.67. What is the difference between the highest and the lowest Pupil-teacher ratio(headcount basis) of Middle East & North Africa (all income levels)?
Your answer should be very brief. 3.32. What is the difference between the highest and the lowest Pupil-teacher ratio(headcount basis) in Cambodia?
Your answer should be compact. 10.76. What is the difference between the highest and the lowest Pupil-teacher ratio(headcount basis) in Oman?
Ensure brevity in your answer.  3.96. 